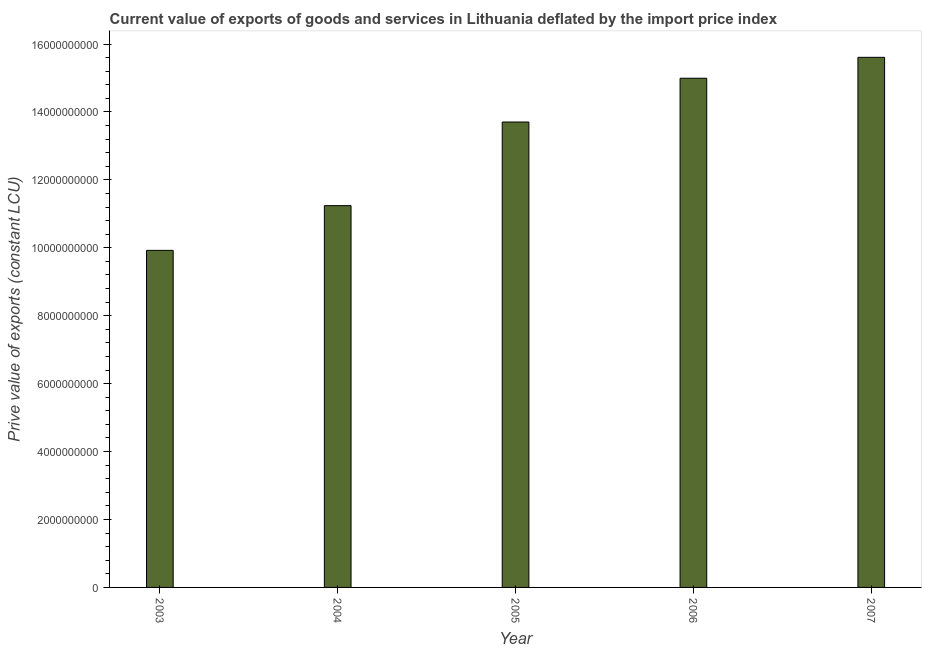What is the title of the graph?
Offer a very short reply. Current value of exports of goods and services in Lithuania deflated by the import price index. What is the label or title of the X-axis?
Offer a very short reply. Year. What is the label or title of the Y-axis?
Your response must be concise. Prive value of exports (constant LCU). What is the price value of exports in 2003?
Provide a succinct answer. 9.92e+09. Across all years, what is the maximum price value of exports?
Offer a very short reply. 1.56e+1. Across all years, what is the minimum price value of exports?
Ensure brevity in your answer.  9.92e+09. In which year was the price value of exports maximum?
Provide a short and direct response. 2007. What is the sum of the price value of exports?
Provide a short and direct response. 6.55e+1. What is the difference between the price value of exports in 2004 and 2006?
Make the answer very short. -3.75e+09. What is the average price value of exports per year?
Offer a very short reply. 1.31e+1. What is the median price value of exports?
Your answer should be compact. 1.37e+1. What is the ratio of the price value of exports in 2003 to that in 2005?
Provide a short and direct response. 0.72. What is the difference between the highest and the second highest price value of exports?
Offer a very short reply. 6.15e+08. Is the sum of the price value of exports in 2003 and 2004 greater than the maximum price value of exports across all years?
Your response must be concise. Yes. What is the difference between the highest and the lowest price value of exports?
Offer a terse response. 5.68e+09. Are the values on the major ticks of Y-axis written in scientific E-notation?
Offer a terse response. No. What is the Prive value of exports (constant LCU) in 2003?
Offer a terse response. 9.92e+09. What is the Prive value of exports (constant LCU) of 2004?
Ensure brevity in your answer.  1.12e+1. What is the Prive value of exports (constant LCU) of 2005?
Provide a short and direct response. 1.37e+1. What is the Prive value of exports (constant LCU) in 2006?
Provide a succinct answer. 1.50e+1. What is the Prive value of exports (constant LCU) in 2007?
Your answer should be very brief. 1.56e+1. What is the difference between the Prive value of exports (constant LCU) in 2003 and 2004?
Your answer should be compact. -1.32e+09. What is the difference between the Prive value of exports (constant LCU) in 2003 and 2005?
Offer a very short reply. -3.78e+09. What is the difference between the Prive value of exports (constant LCU) in 2003 and 2006?
Offer a terse response. -5.07e+09. What is the difference between the Prive value of exports (constant LCU) in 2003 and 2007?
Provide a succinct answer. -5.68e+09. What is the difference between the Prive value of exports (constant LCU) in 2004 and 2005?
Give a very brief answer. -2.46e+09. What is the difference between the Prive value of exports (constant LCU) in 2004 and 2006?
Ensure brevity in your answer.  -3.75e+09. What is the difference between the Prive value of exports (constant LCU) in 2004 and 2007?
Ensure brevity in your answer.  -4.37e+09. What is the difference between the Prive value of exports (constant LCU) in 2005 and 2006?
Ensure brevity in your answer.  -1.29e+09. What is the difference between the Prive value of exports (constant LCU) in 2005 and 2007?
Provide a succinct answer. -1.90e+09. What is the difference between the Prive value of exports (constant LCU) in 2006 and 2007?
Your response must be concise. -6.15e+08. What is the ratio of the Prive value of exports (constant LCU) in 2003 to that in 2004?
Provide a short and direct response. 0.88. What is the ratio of the Prive value of exports (constant LCU) in 2003 to that in 2005?
Provide a short and direct response. 0.72. What is the ratio of the Prive value of exports (constant LCU) in 2003 to that in 2006?
Offer a very short reply. 0.66. What is the ratio of the Prive value of exports (constant LCU) in 2003 to that in 2007?
Offer a very short reply. 0.64. What is the ratio of the Prive value of exports (constant LCU) in 2004 to that in 2005?
Provide a short and direct response. 0.82. What is the ratio of the Prive value of exports (constant LCU) in 2004 to that in 2007?
Offer a very short reply. 0.72. What is the ratio of the Prive value of exports (constant LCU) in 2005 to that in 2006?
Your answer should be very brief. 0.91. What is the ratio of the Prive value of exports (constant LCU) in 2005 to that in 2007?
Your response must be concise. 0.88. What is the ratio of the Prive value of exports (constant LCU) in 2006 to that in 2007?
Your answer should be compact. 0.96. 